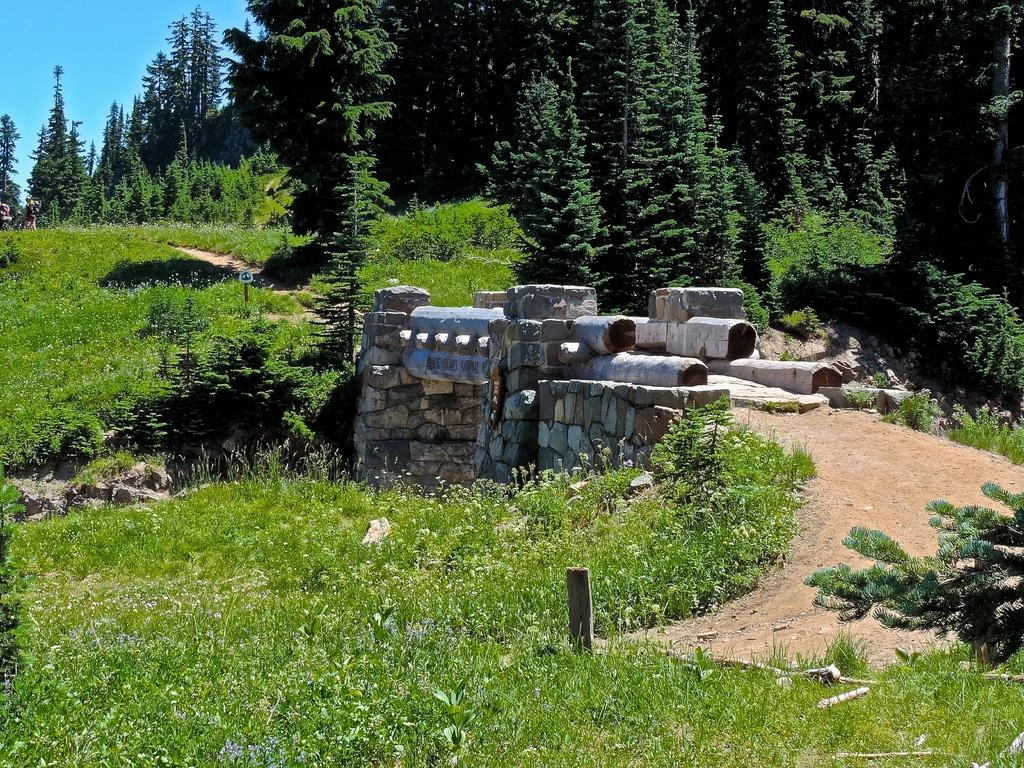What is the main structure in the foreground of the image? There is a bridge in the foreground of the image. What type of vegetation can be seen in the image? There are trees in the image. What part of the sky is visible in the image? The sky is visible in the top left corner of the image. What type of terrain is present in the image? There is grass on the land in the image. What is the governor's son doing in the image? There is no reference to a governor or a son in the image, so it is not possible to answer that question. 